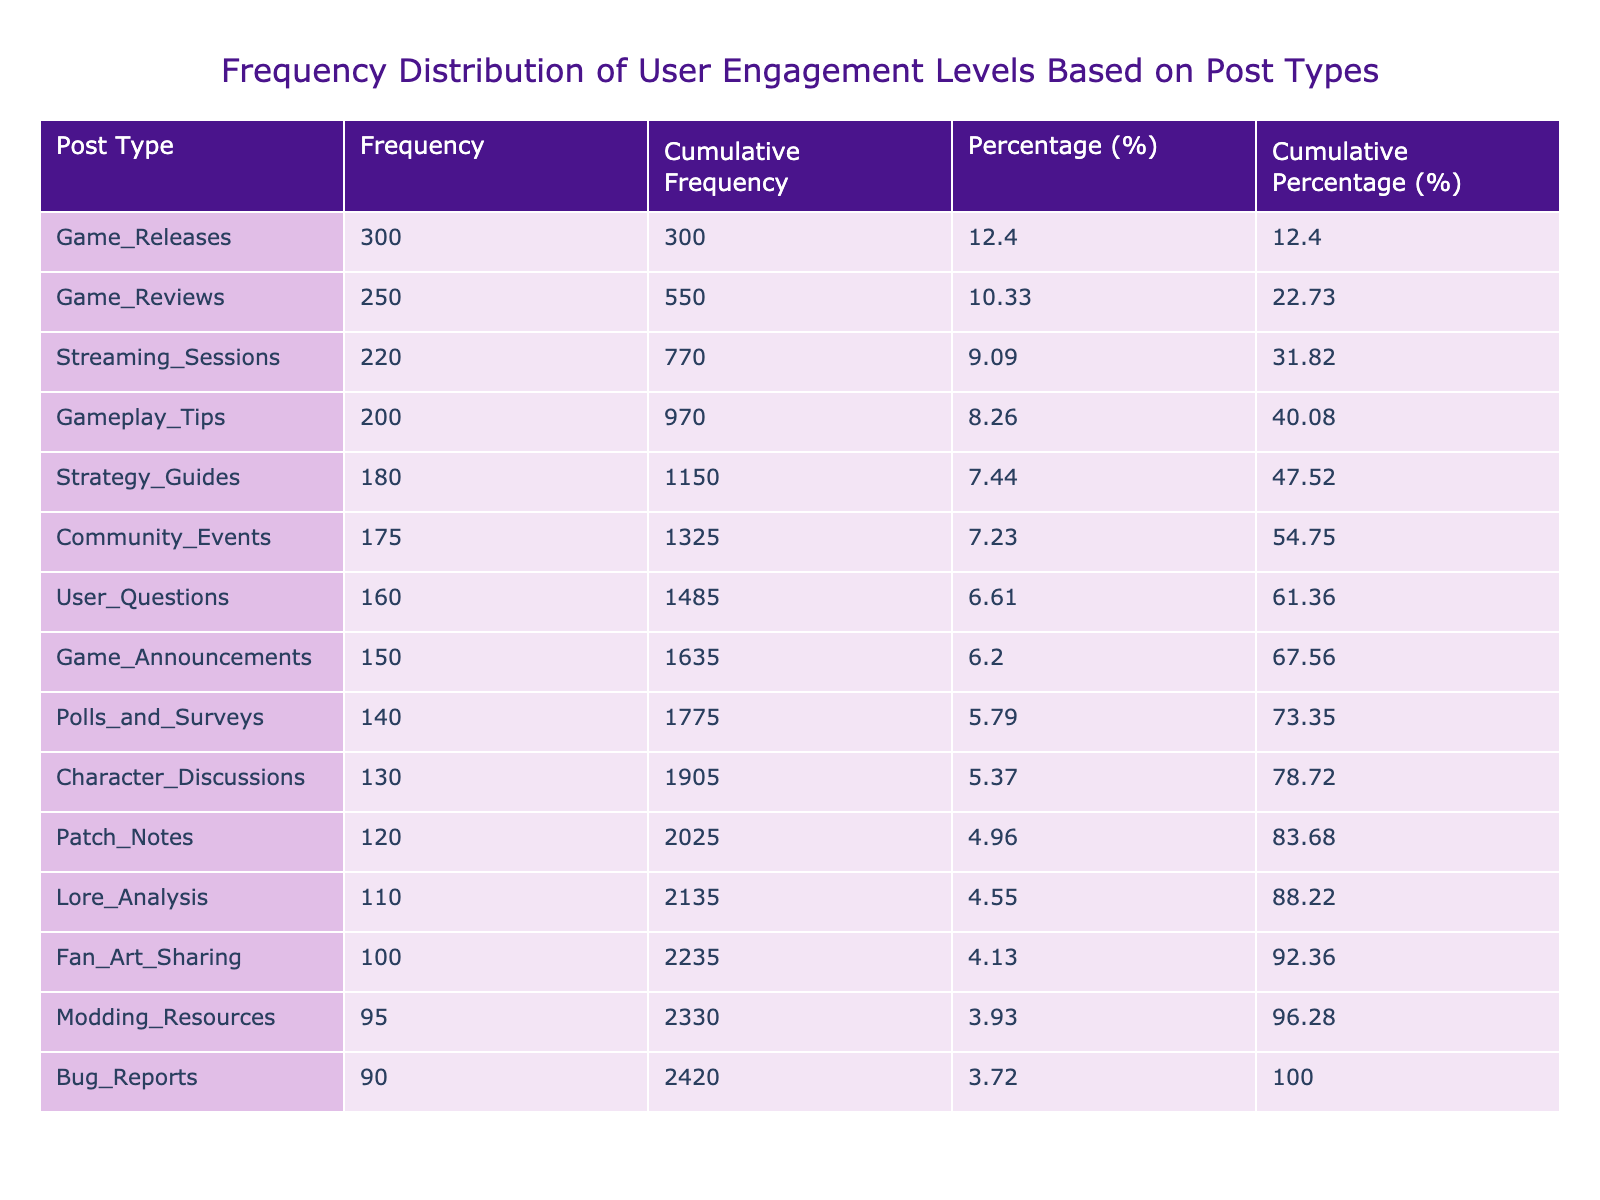What is the highest user engagement level among the post types? The table indicates that "Game_Releases" has the highest user engagement level with a value of 300.
Answer: 300 Which post type has the second highest user engagement level? By examining the sorted list in the table, "Game_Reviews" follows "Game_Releases" with a user engagement level of 250.
Answer: 250 What is the cumulative frequency for "Gameplay_Tips"? The cumulative frequency for "Gameplay_Tips" is found by adding its engagement level (200) to the levels above it (300 + 250), resulting in 950.
Answer: 950 How many post types have an engagement level below 150? Looking at the table, the post types under 150 are "Fan_Art_Sharing" (100), "Bug_Reports" (90), "Lore_Analysis" (110), and "Modding_Resources" (95), totaling 4 types.
Answer: 4 Is the user engagement level for "Patch_Notes" higher than "Bug_Reports"? The level for "Patch_Notes" is 120, while "Bug_Reports" is 90, thus it is true that "Patch_Notes" has a higher engagement level.
Answer: Yes What is the average user engagement level of the first three post types? The user engagement levels for the first three post types are 300, 250, and 220. Summing these gives 770, and dividing by 3 gives an average of approximately 256.67.
Answer: Approximately 256.67 What is the cumulative percentage for "Streaming_Sessions"? To find the cumulative percentage for "Streaming_Sessions," we check its own percentage (about 15.56) and add the percentages of all preceding post types, resulting in about 61.67%.
Answer: Approximately 61.67% How many post types have an engagement level greater than 180? By counting the post types with levels greater than 180— "Game_Releases" (300), "Game_Reviews" (250), "Streaming_Sessions" (220), and "Gameplay_Tips" (200)—there are 4 types.
Answer: 4 